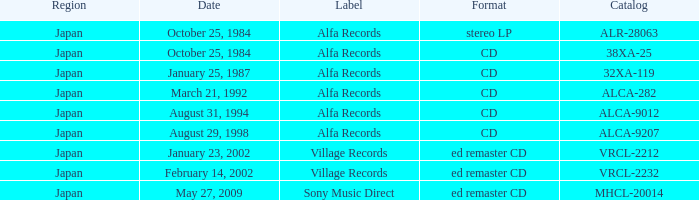What is the catalog of the release from January 23, 2002? VRCL-2212. 